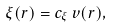<formula> <loc_0><loc_0><loc_500><loc_500>\xi ( { r } ) = c _ { \xi } \, v ( { r } ) ,</formula> 